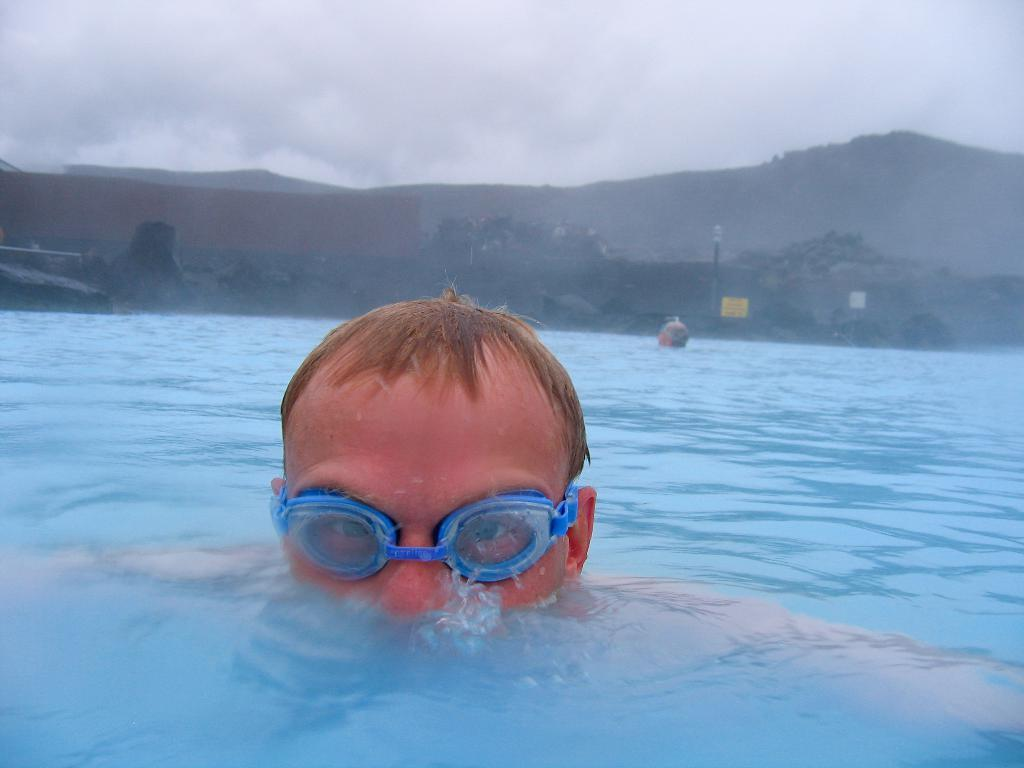What are the people in the image doing? The people in the image are in the water. What can be seen in the background of the image? There is a mountain in the background of the image. How would you describe the sky in the image? The sky is cloudy in the image. What type of plot is visible in the image? There is no plot visible in the image; it features people in the water with a mountain in the background and a cloudy sky. Can you see any copper objects in the image? There are no copper objects present in the image. 